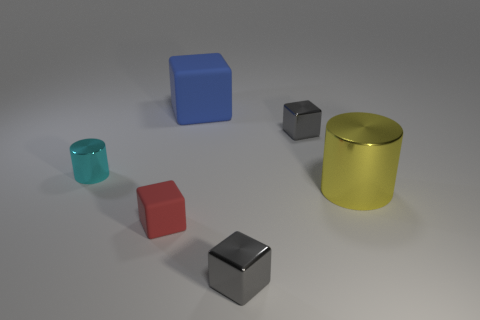Subtract all brown cubes. Subtract all green spheres. How many cubes are left? 4 Add 2 gray metallic balls. How many objects exist? 8 Subtract all cylinders. How many objects are left? 4 Subtract all big yellow metal cylinders. Subtract all small green metallic objects. How many objects are left? 5 Add 2 tiny cylinders. How many tiny cylinders are left? 3 Add 2 brown cubes. How many brown cubes exist? 2 Subtract 1 cyan cylinders. How many objects are left? 5 